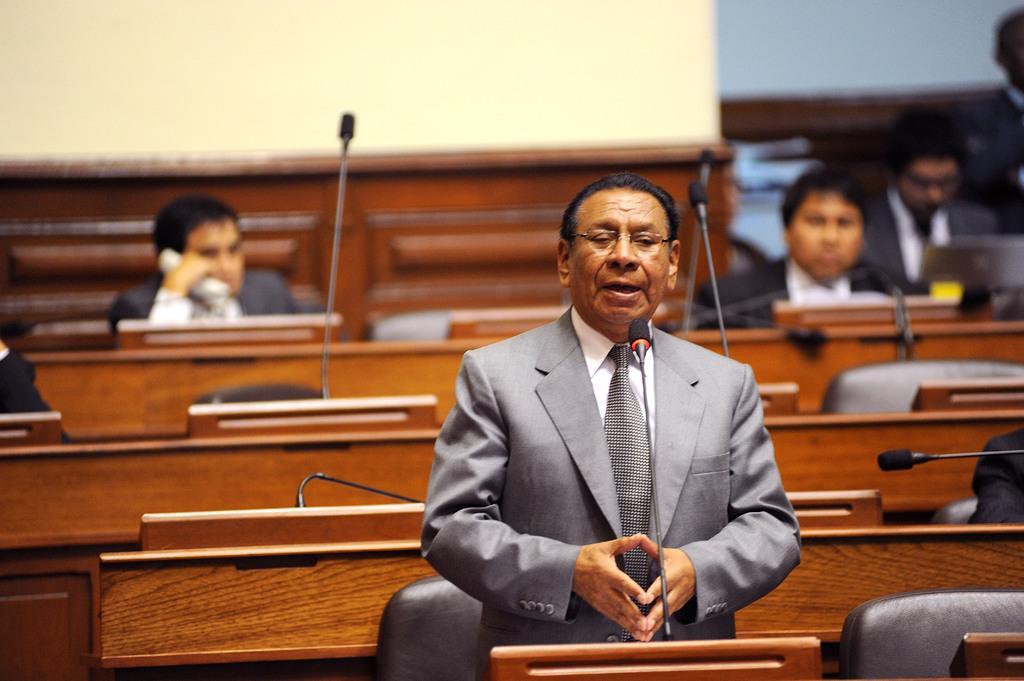Describe this image in one or two sentences. In this picture I can see a man in front and I see that he is wearing formal dress and I can see a mic in front of him. In the background I can see the tables, chairs, few more mics and people and I can see the wall. 